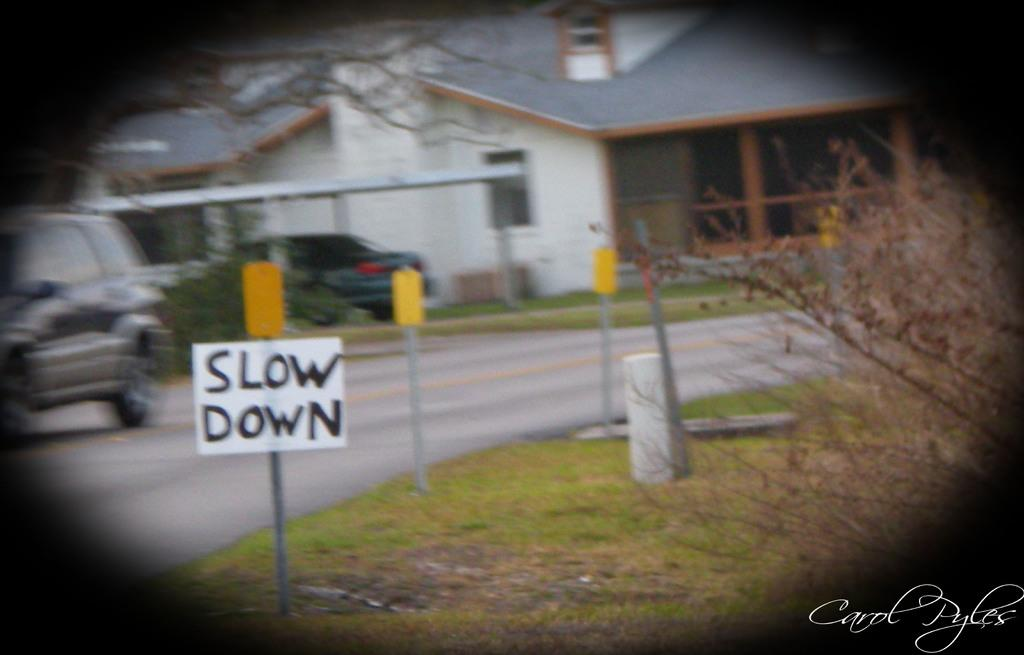What is the main object in the image? There is a board in the image. What else can be seen in the image besides the board? There are vehicles, a road, poles, plants, grass, trees, and houses in the image. Can you describe the setting of the image? The image features a road, houses, and natural elements such as plants, grass, and trees. What type of structures are present in the image? There are houses and poles in the image. How many chickens can be seen on the coast in the image? There are no chickens or coast present in the image. What type of building is visible in the image? There is no building visible in the image; only a board, vehicles, a road, poles, plants, grass, trees, and houses are present. 